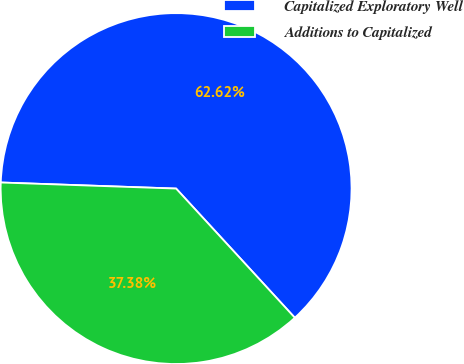<chart> <loc_0><loc_0><loc_500><loc_500><pie_chart><fcel>Capitalized Exploratory Well<fcel>Additions to Capitalized<nl><fcel>62.62%<fcel>37.38%<nl></chart> 